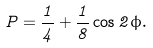<formula> <loc_0><loc_0><loc_500><loc_500>P = \frac { 1 } { 4 } + \frac { 1 } { 8 } \cos 2 \phi .</formula> 